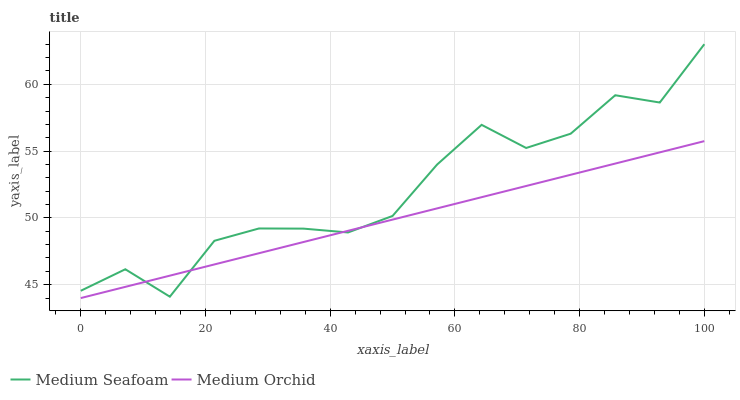Does Medium Orchid have the minimum area under the curve?
Answer yes or no. Yes. Does Medium Seafoam have the maximum area under the curve?
Answer yes or no. Yes. Does Medium Seafoam have the minimum area under the curve?
Answer yes or no. No. Is Medium Orchid the smoothest?
Answer yes or no. Yes. Is Medium Seafoam the roughest?
Answer yes or no. Yes. Is Medium Seafoam the smoothest?
Answer yes or no. No. Does Medium Orchid have the lowest value?
Answer yes or no. Yes. Does Medium Seafoam have the lowest value?
Answer yes or no. No. Does Medium Seafoam have the highest value?
Answer yes or no. Yes. Does Medium Seafoam intersect Medium Orchid?
Answer yes or no. Yes. Is Medium Seafoam less than Medium Orchid?
Answer yes or no. No. Is Medium Seafoam greater than Medium Orchid?
Answer yes or no. No. 